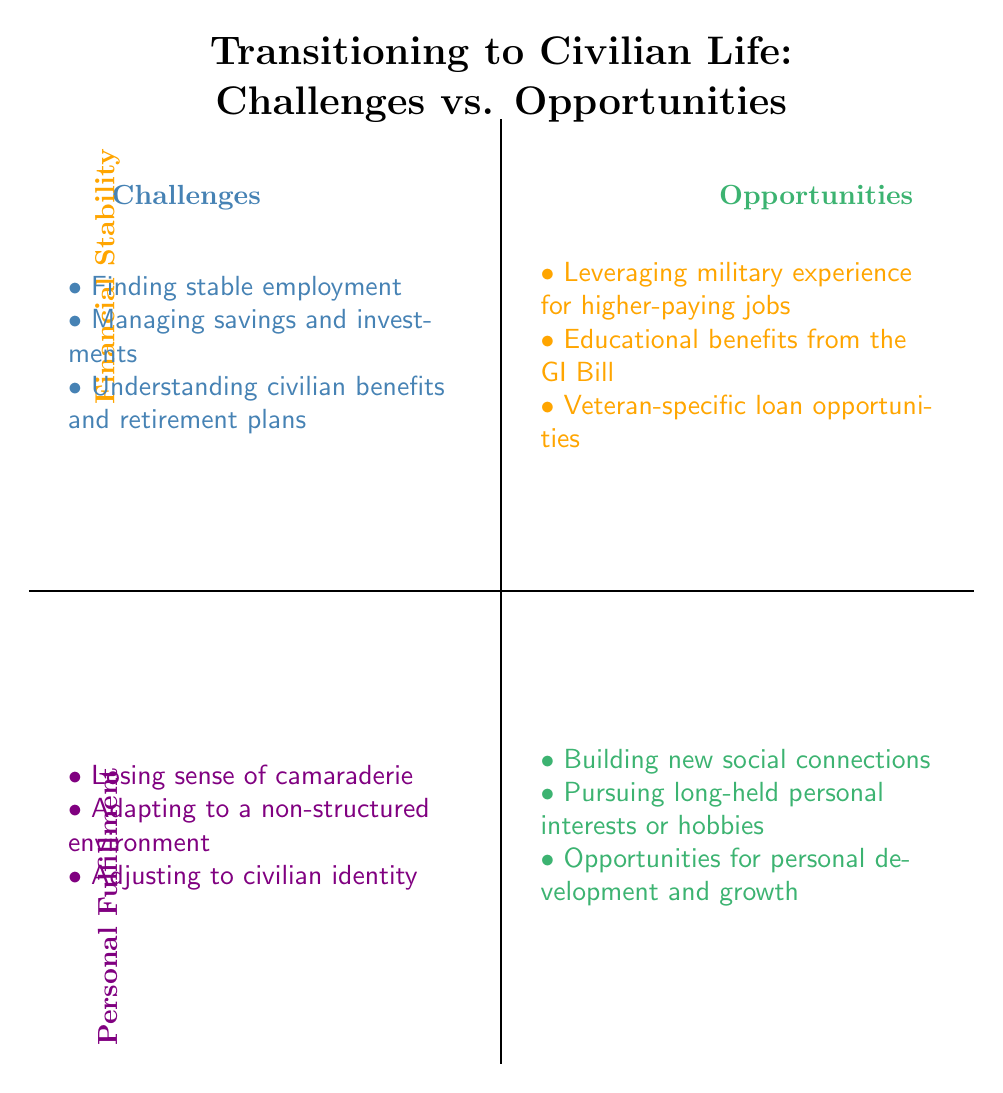What are the challenges related to financial stability? The diagram shows three specific challenges in the financial stability quadrant: "Finding stable employment", "Managing savings and investments", and "Understanding civilian benefits and retirement plans".
Answer: Finding stable employment, Managing savings and investments, Understanding civilian benefits and retirement plans How many opportunities exist in the personal fulfillment quadrant? The diagram lists three opportunities under personal fulfillment: "Building new social connections", "Pursuing long-held personal interests or hobbies", and "Opportunities for personal development and growth". Therefore, the total count is three.
Answer: 3 What is the relationship between financial stability challenges and personal fulfillment challenges? Both financial stability challenges and personal fulfillment challenges belong to the challenges quadrant. This indicates that they deal with difficulties faced while transitioning to civilian life.
Answer: Both belong to challenges quadrant Which opportunity directly follows leveraging military experience for higher-paying jobs? The opportunity listed directly after "Leveraging military experience for higher-paying jobs" in the opportunities for financial stability quadrant is "Educational benefits from the GI Bill".
Answer: Educational benefits from the GI Bill Which two quadrants are compared in this diagram? The diagram features two main quadrants, "Challenges" and "Opportunities", across both financial stability and personal fulfillment axes. This comparison illustrates the difficulties versus the prospects faced when transitioning to civilian life.
Answer: Challenges and Opportunities What represents the personal fulfillment challenges in this quadrant chart? The challenges for personal fulfillment indicated in the diagram include: "Losing sense of camaraderie", "Adapting to a non-structured environment", and "Adjusting to civilian identity." These are the challenges designated under personal fulfillment.
Answer: Losing sense of camaraderie, Adapting to a non-structured environment, Adjusting to civilian identity Which quadrant offers educational benefits from the GI Bill? The "Opportunities" quadrant offers educational benefits from the GI Bill, suggesting that transitioning veterans can leverage these benefits for personal growth and financial stability in civilian life.
Answer: Opportunities quadrant 